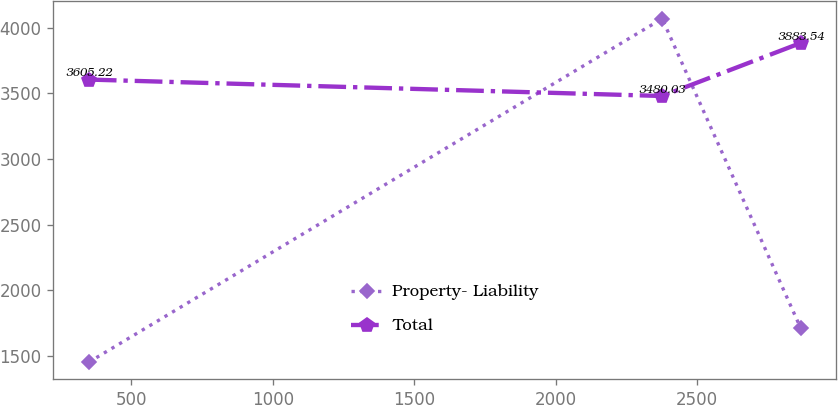Convert chart. <chart><loc_0><loc_0><loc_500><loc_500><line_chart><ecel><fcel>Property- Liability<fcel>Total<nl><fcel>349.56<fcel>1451.66<fcel>3605.22<nl><fcel>2376.12<fcel>4069.25<fcel>3480.03<nl><fcel>2865.41<fcel>1713.42<fcel>3883.54<nl></chart> 